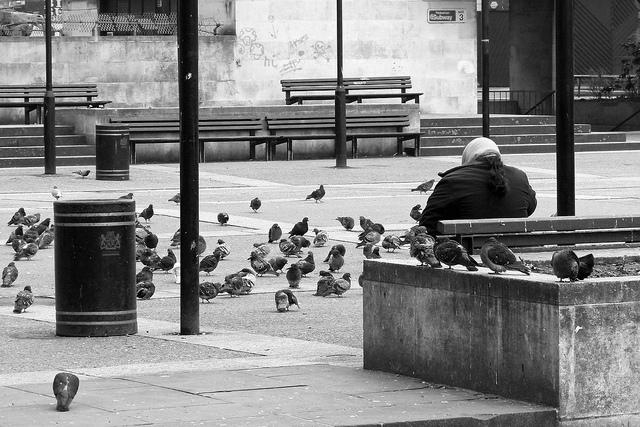Why are all the pigeons around the woman? Please explain your reasoning. feeding them. The pigeons are getting fed. 